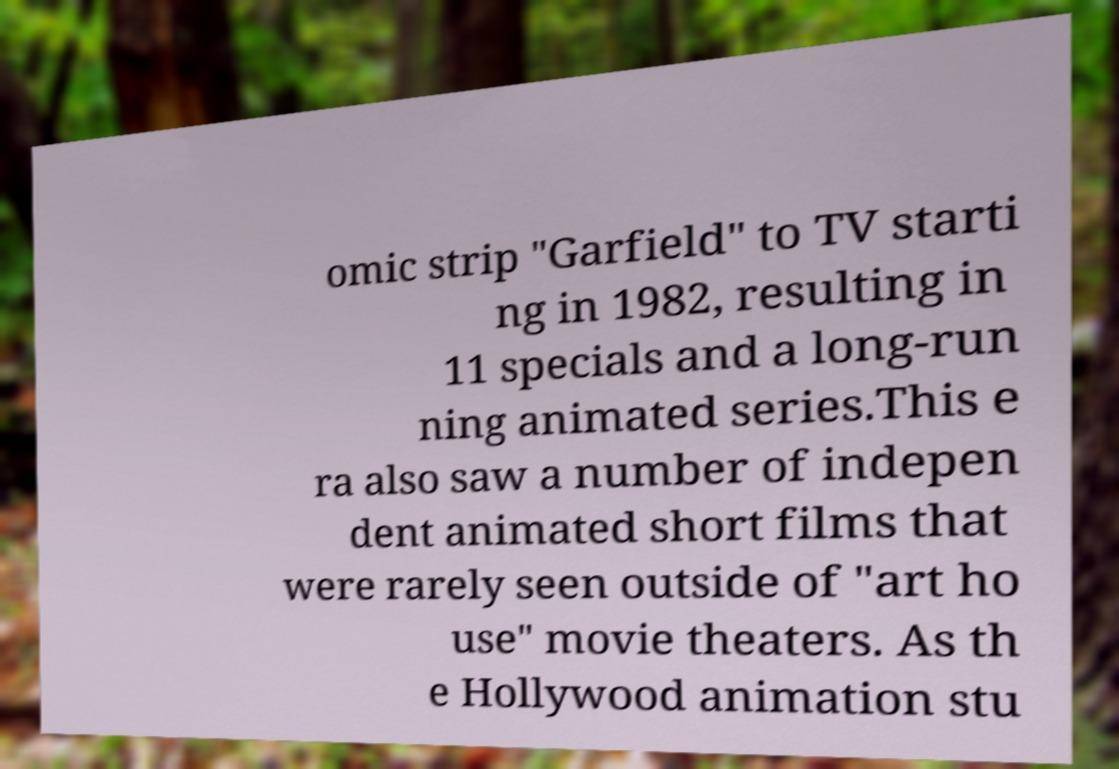Could you assist in decoding the text presented in this image and type it out clearly? omic strip "Garfield" to TV starti ng in 1982, resulting in 11 specials and a long-run ning animated series.This e ra also saw a number of indepen dent animated short films that were rarely seen outside of "art ho use" movie theaters. As th e Hollywood animation stu 